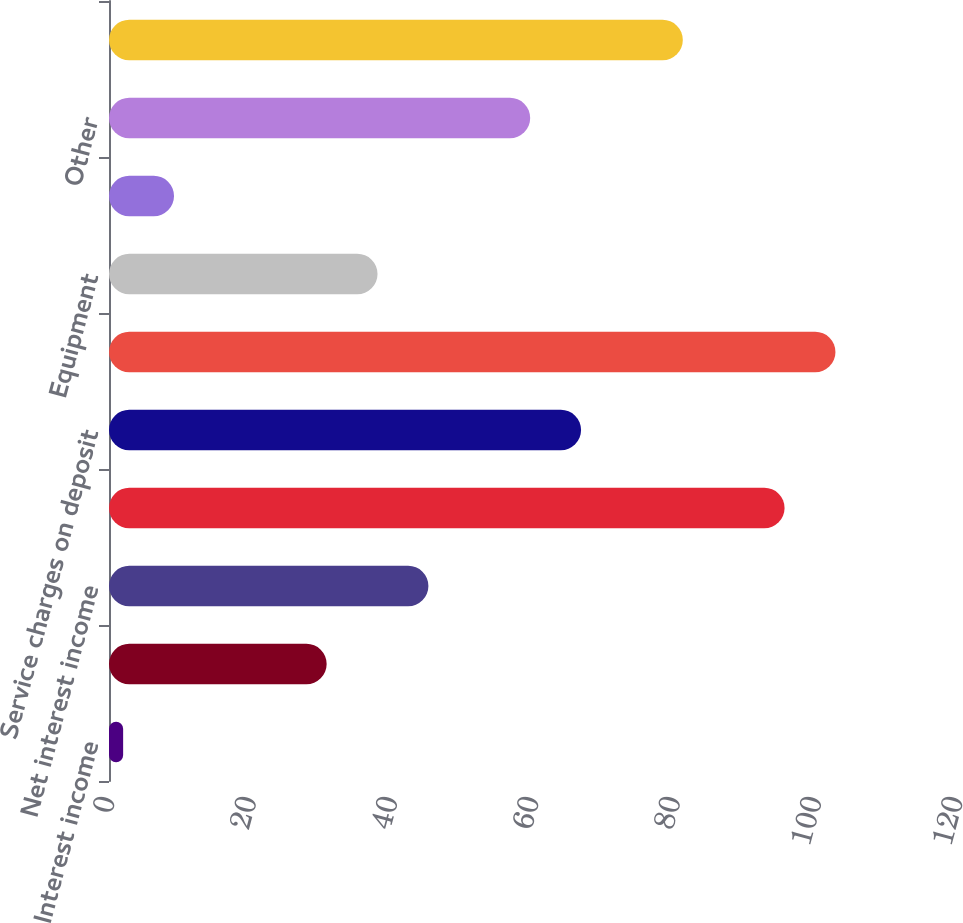Convert chart. <chart><loc_0><loc_0><loc_500><loc_500><bar_chart><fcel>Interest income<fcel>Interest expense<fcel>Net interest income<fcel>Provision for credit losses<fcel>Service charges on deposit<fcel>Totalnoninterest income<fcel>Equipment<fcel>Telecommunications<fcel>Other<fcel>Average common shares - basic<nl><fcel>2<fcel>30.8<fcel>45.2<fcel>95.6<fcel>66.8<fcel>102.8<fcel>38<fcel>9.2<fcel>59.6<fcel>81.2<nl></chart> 